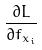<formula> <loc_0><loc_0><loc_500><loc_500>\frac { \partial L } { \partial f _ { x _ { i } } }</formula> 